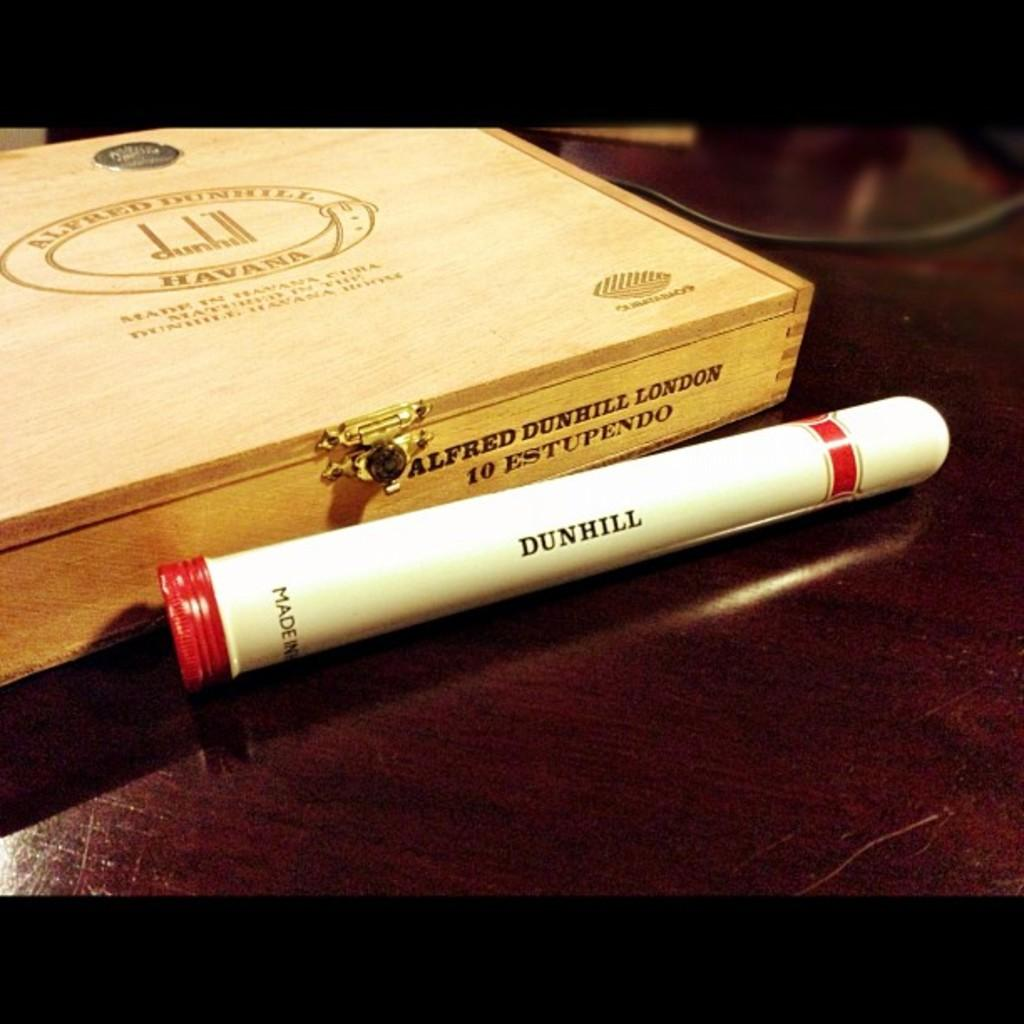<image>
Write a terse but informative summary of the picture. A Dunhill cigar inside a white and red cigar shaped vessel, next to the cigar a wooden box. 